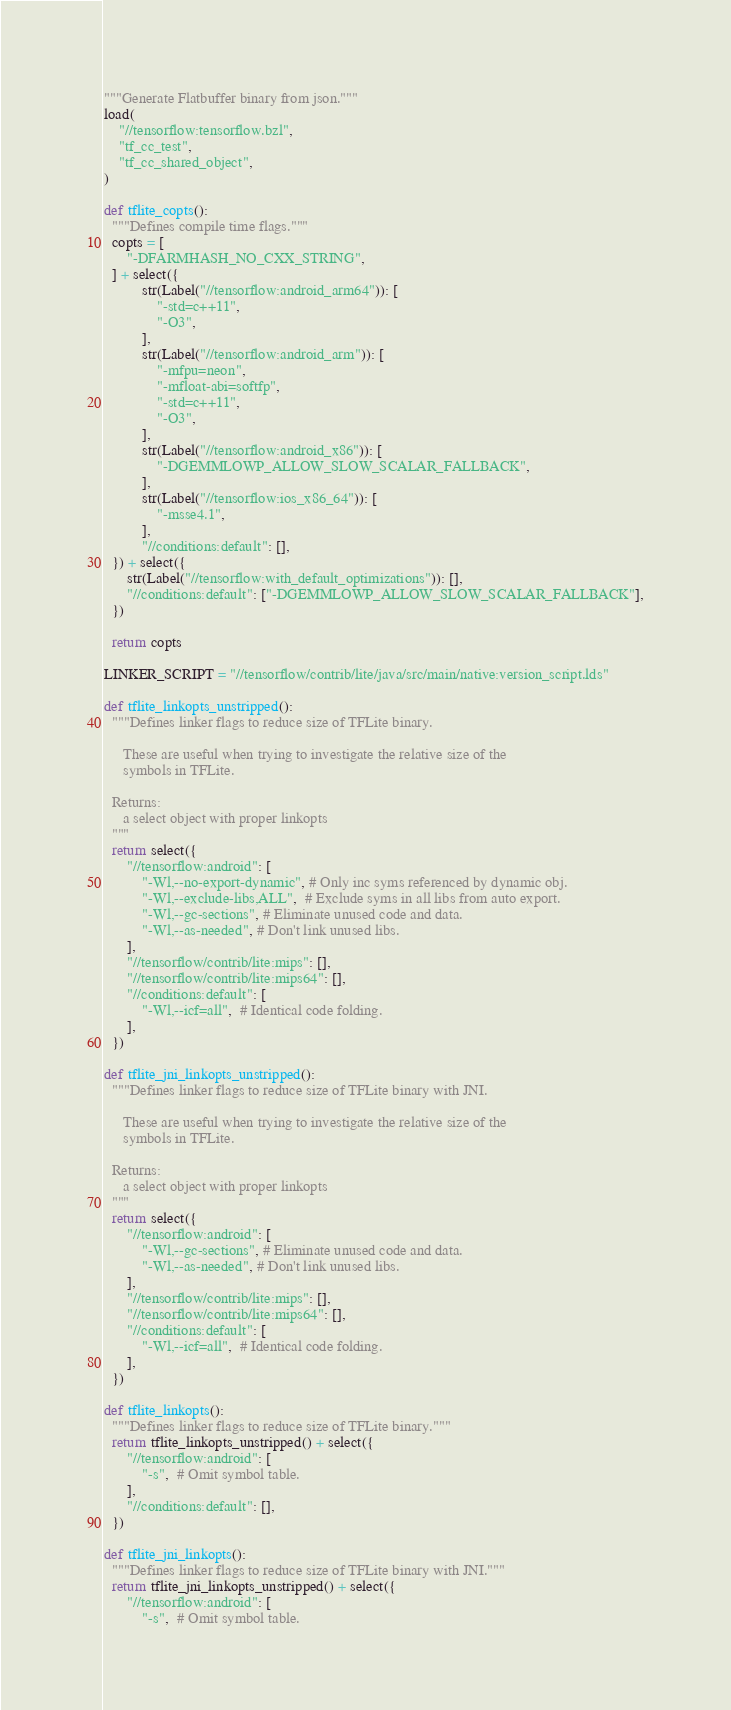<code> <loc_0><loc_0><loc_500><loc_500><_Python_>"""Generate Flatbuffer binary from json."""
load(
    "//tensorflow:tensorflow.bzl",
    "tf_cc_test",
    "tf_cc_shared_object",
)

def tflite_copts():
  """Defines compile time flags."""
  copts = [
      "-DFARMHASH_NO_CXX_STRING",
  ] + select({
          str(Label("//tensorflow:android_arm64")): [
              "-std=c++11",
              "-O3",
          ],
          str(Label("//tensorflow:android_arm")): [
              "-mfpu=neon",
              "-mfloat-abi=softfp",
              "-std=c++11",
              "-O3",
          ],
          str(Label("//tensorflow:android_x86")): [
              "-DGEMMLOWP_ALLOW_SLOW_SCALAR_FALLBACK",
          ],
          str(Label("//tensorflow:ios_x86_64")): [
              "-msse4.1",
          ],
          "//conditions:default": [],
  }) + select({
      str(Label("//tensorflow:with_default_optimizations")): [],
      "//conditions:default": ["-DGEMMLOWP_ALLOW_SLOW_SCALAR_FALLBACK"],
  })

  return copts

LINKER_SCRIPT = "//tensorflow/contrib/lite/java/src/main/native:version_script.lds"

def tflite_linkopts_unstripped():
  """Defines linker flags to reduce size of TFLite binary.

     These are useful when trying to investigate the relative size of the
     symbols in TFLite.

  Returns:
     a select object with proper linkopts
  """
  return select({
      "//tensorflow:android": [
          "-Wl,--no-export-dynamic", # Only inc syms referenced by dynamic obj.
          "-Wl,--exclude-libs,ALL",  # Exclude syms in all libs from auto export.
          "-Wl,--gc-sections", # Eliminate unused code and data.
          "-Wl,--as-needed", # Don't link unused libs.
      ],
      "//tensorflow/contrib/lite:mips": [],
      "//tensorflow/contrib/lite:mips64": [],
      "//conditions:default": [
          "-Wl,--icf=all",  # Identical code folding.
      ],
  })

def tflite_jni_linkopts_unstripped():
  """Defines linker flags to reduce size of TFLite binary with JNI.

     These are useful when trying to investigate the relative size of the
     symbols in TFLite.

  Returns:
     a select object with proper linkopts
  """
  return select({
      "//tensorflow:android": [
          "-Wl,--gc-sections", # Eliminate unused code and data.
          "-Wl,--as-needed", # Don't link unused libs.
      ],
      "//tensorflow/contrib/lite:mips": [],
      "//tensorflow/contrib/lite:mips64": [],
      "//conditions:default": [
          "-Wl,--icf=all",  # Identical code folding.
      ],
  })

def tflite_linkopts():
  """Defines linker flags to reduce size of TFLite binary."""
  return tflite_linkopts_unstripped() + select({
      "//tensorflow:android": [
          "-s",  # Omit symbol table.
      ],
      "//conditions:default": [],
  })

def tflite_jni_linkopts():
  """Defines linker flags to reduce size of TFLite binary with JNI."""
  return tflite_jni_linkopts_unstripped() + select({
      "//tensorflow:android": [
          "-s",  # Omit symbol table.</code> 